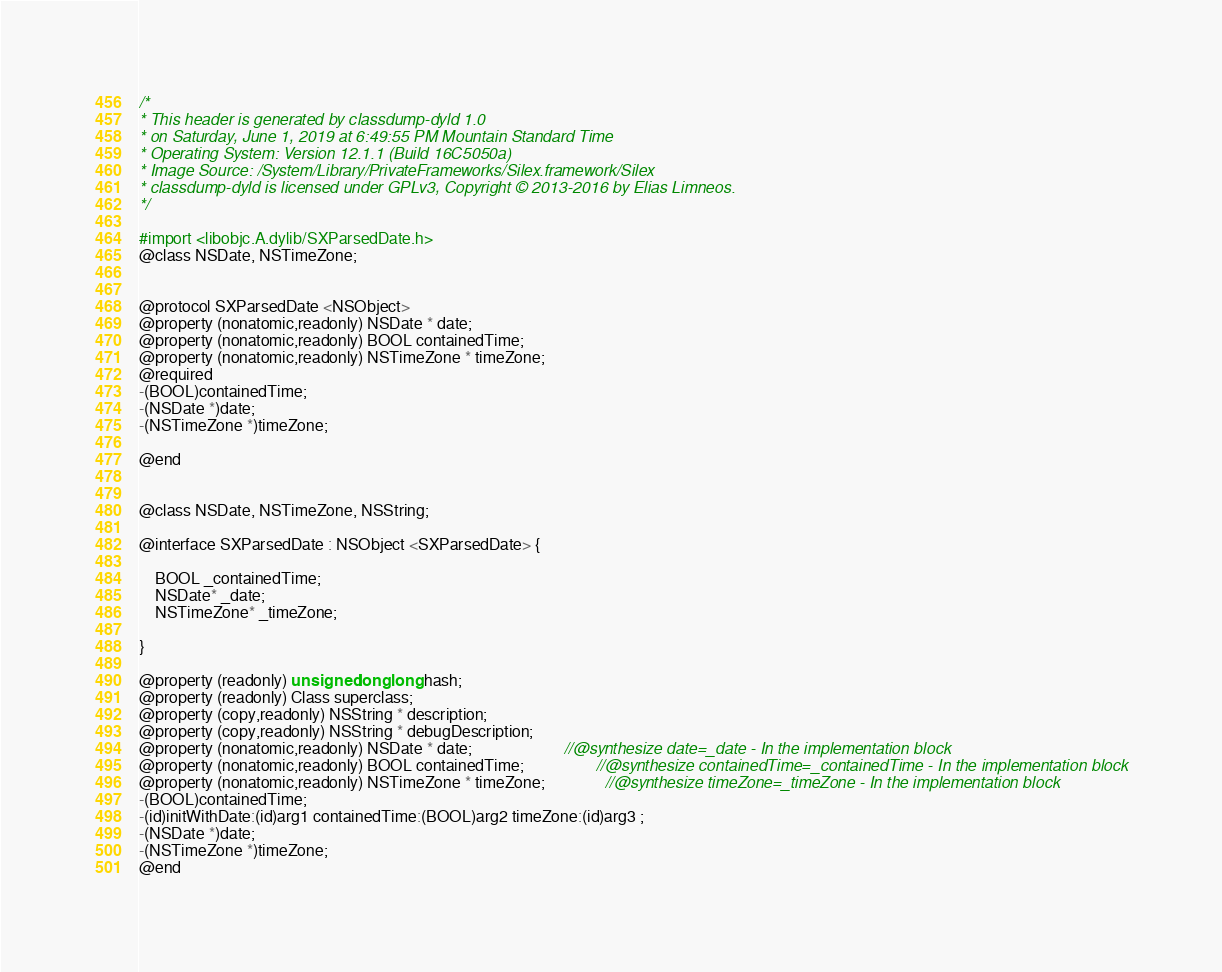<code> <loc_0><loc_0><loc_500><loc_500><_C_>/*
* This header is generated by classdump-dyld 1.0
* on Saturday, June 1, 2019 at 6:49:55 PM Mountain Standard Time
* Operating System: Version 12.1.1 (Build 16C5050a)
* Image Source: /System/Library/PrivateFrameworks/Silex.framework/Silex
* classdump-dyld is licensed under GPLv3, Copyright © 2013-2016 by Elias Limneos.
*/

#import <libobjc.A.dylib/SXParsedDate.h>
@class NSDate, NSTimeZone;


@protocol SXParsedDate <NSObject>
@property (nonatomic,readonly) NSDate * date; 
@property (nonatomic,readonly) BOOL containedTime; 
@property (nonatomic,readonly) NSTimeZone * timeZone; 
@required
-(BOOL)containedTime;
-(NSDate *)date;
-(NSTimeZone *)timeZone;

@end


@class NSDate, NSTimeZone, NSString;

@interface SXParsedDate : NSObject <SXParsedDate> {

	BOOL _containedTime;
	NSDate* _date;
	NSTimeZone* _timeZone;

}

@property (readonly) unsigned long long hash; 
@property (readonly) Class superclass; 
@property (copy,readonly) NSString * description; 
@property (copy,readonly) NSString * debugDescription; 
@property (nonatomic,readonly) NSDate * date;                       //@synthesize date=_date - In the implementation block
@property (nonatomic,readonly) BOOL containedTime;                  //@synthesize containedTime=_containedTime - In the implementation block
@property (nonatomic,readonly) NSTimeZone * timeZone;               //@synthesize timeZone=_timeZone - In the implementation block
-(BOOL)containedTime;
-(id)initWithDate:(id)arg1 containedTime:(BOOL)arg2 timeZone:(id)arg3 ;
-(NSDate *)date;
-(NSTimeZone *)timeZone;
@end

</code> 